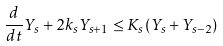<formula> <loc_0><loc_0><loc_500><loc_500>\frac { d } { d t } Y _ { s } + 2 k _ { s } Y _ { s + 1 } \leq K _ { s } ( Y _ { s } + Y _ { s - 2 } )</formula> 